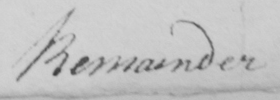What text is written in this handwritten line? Remainder 